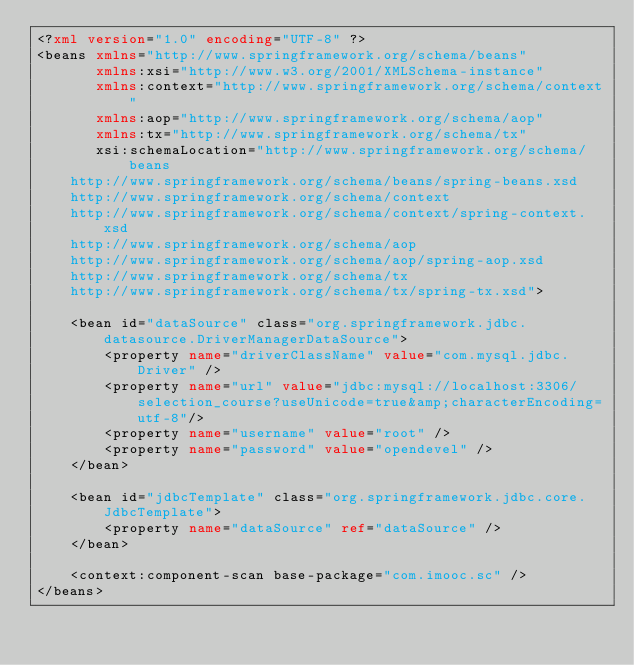Convert code to text. <code><loc_0><loc_0><loc_500><loc_500><_XML_><?xml version="1.0" encoding="UTF-8" ?>
<beans xmlns="http://www.springframework.org/schema/beans"
       xmlns:xsi="http://www.w3.org/2001/XMLSchema-instance"
       xmlns:context="http://www.springframework.org/schema/context"
       xmlns:aop="http://www.springframework.org/schema/aop"
       xmlns:tx="http://www.springframework.org/schema/tx"
       xsi:schemaLocation="http://www.springframework.org/schema/beans
    http://www.springframework.org/schema/beans/spring-beans.xsd
    http://www.springframework.org/schema/context
    http://www.springframework.org/schema/context/spring-context.xsd
    http://www.springframework.org/schema/aop
    http://www.springframework.org/schema/aop/spring-aop.xsd
    http://www.springframework.org/schema/tx
    http://www.springframework.org/schema/tx/spring-tx.xsd">

    <bean id="dataSource" class="org.springframework.jdbc.datasource.DriverManagerDataSource">
        <property name="driverClassName" value="com.mysql.jdbc.Driver" />
        <property name="url" value="jdbc:mysql://localhost:3306/selection_course?useUnicode=true&amp;characterEncoding=utf-8"/>
        <property name="username" value="root" />
        <property name="password" value="opendevel" />
    </bean>

    <bean id="jdbcTemplate" class="org.springframework.jdbc.core.JdbcTemplate">
        <property name="dataSource" ref="dataSource" />
    </bean>

    <context:component-scan base-package="com.imooc.sc" />
</beans></code> 